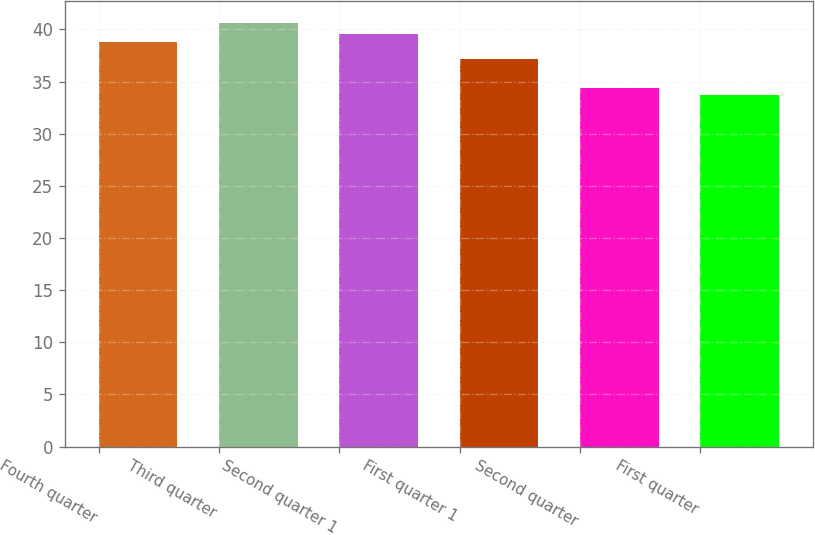Convert chart to OTSL. <chart><loc_0><loc_0><loc_500><loc_500><bar_chart><fcel>Fourth quarter<fcel>Third quarter<fcel>Second quarter 1<fcel>First quarter 1<fcel>Second quarter<fcel>First quarter<nl><fcel>38.83<fcel>40.66<fcel>39.52<fcel>37.2<fcel>34.43<fcel>33.74<nl></chart> 